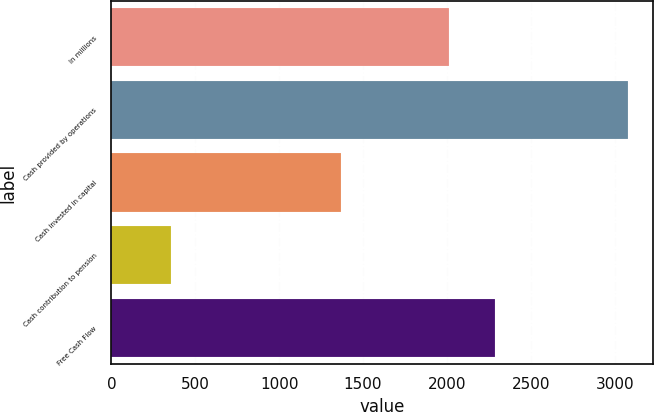<chart> <loc_0><loc_0><loc_500><loc_500><bar_chart><fcel>In millions<fcel>Cash provided by operations<fcel>Cash invested in capital<fcel>Cash contribution to pension<fcel>Free Cash Flow<nl><fcel>2014<fcel>3077<fcel>1366<fcel>353<fcel>2286.4<nl></chart> 